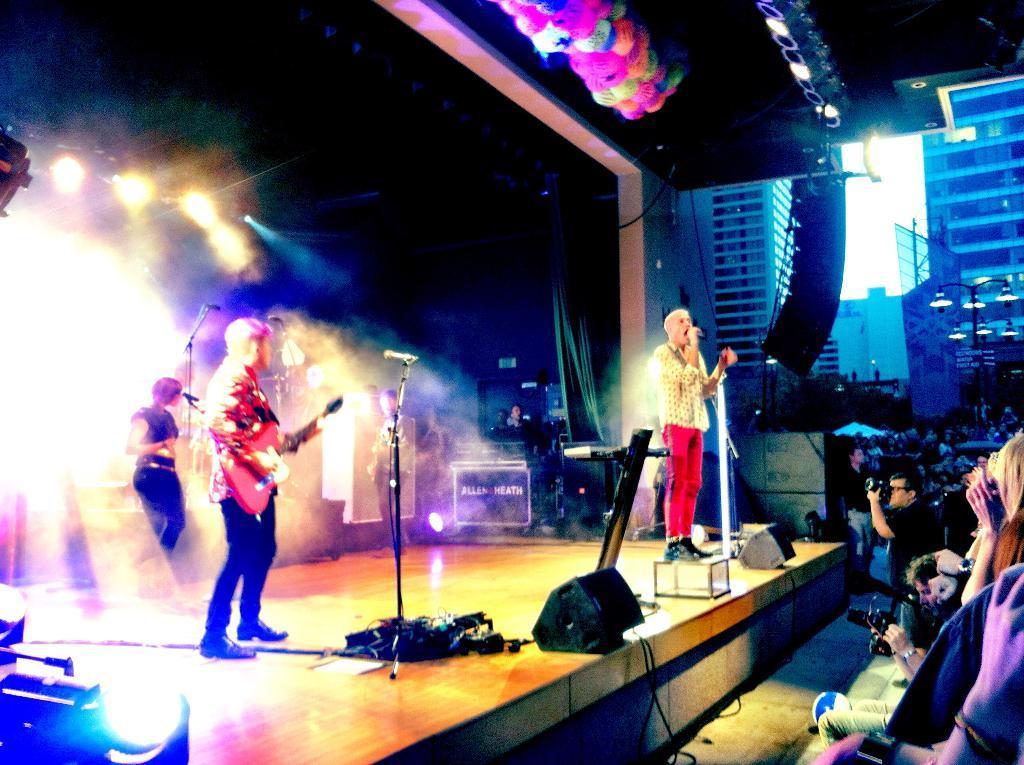How would you summarize this image in a sentence or two? In this image, there are three persons playing musical instruments on a stage, in front of them there are mice, in the background there are lights, on the right side there are people sitting on chairs. 